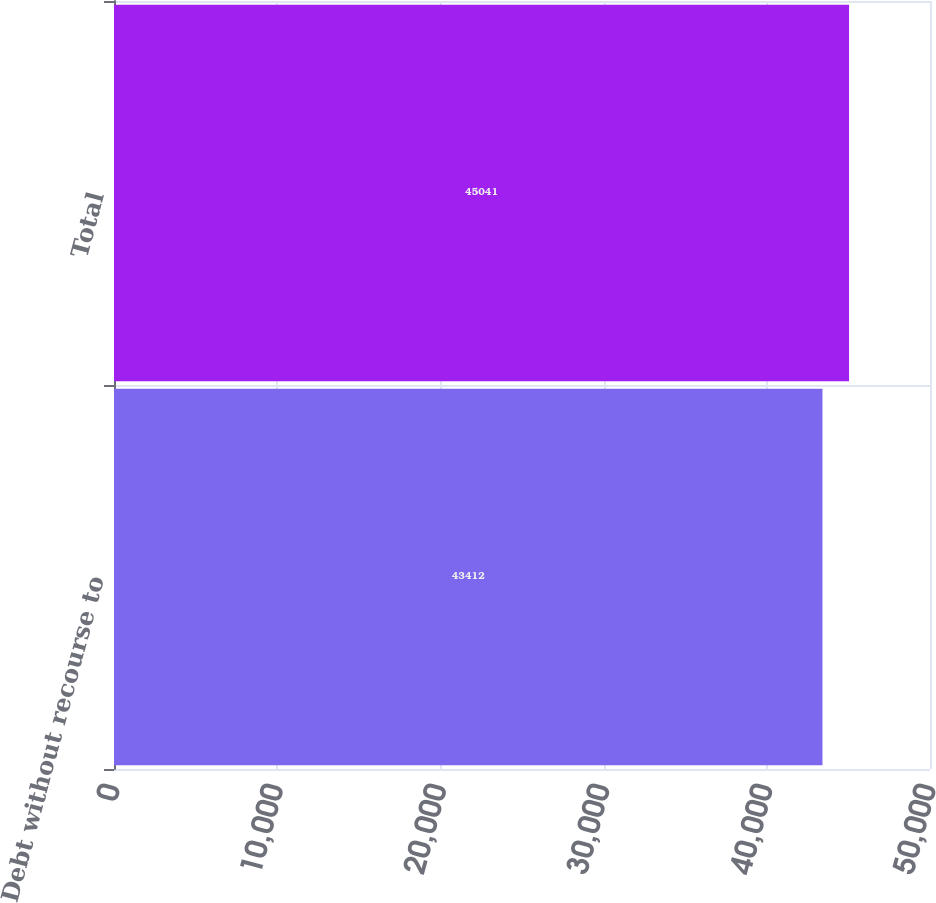Convert chart to OTSL. <chart><loc_0><loc_0><loc_500><loc_500><bar_chart><fcel>Debt without recourse to<fcel>Total<nl><fcel>43412<fcel>45041<nl></chart> 